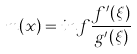<formula> <loc_0><loc_0><loc_500><loc_500>m ( x ) = i n f \frac { f ^ { \prime } ( \xi ) } { g ^ { \prime } ( \xi ) }</formula> 